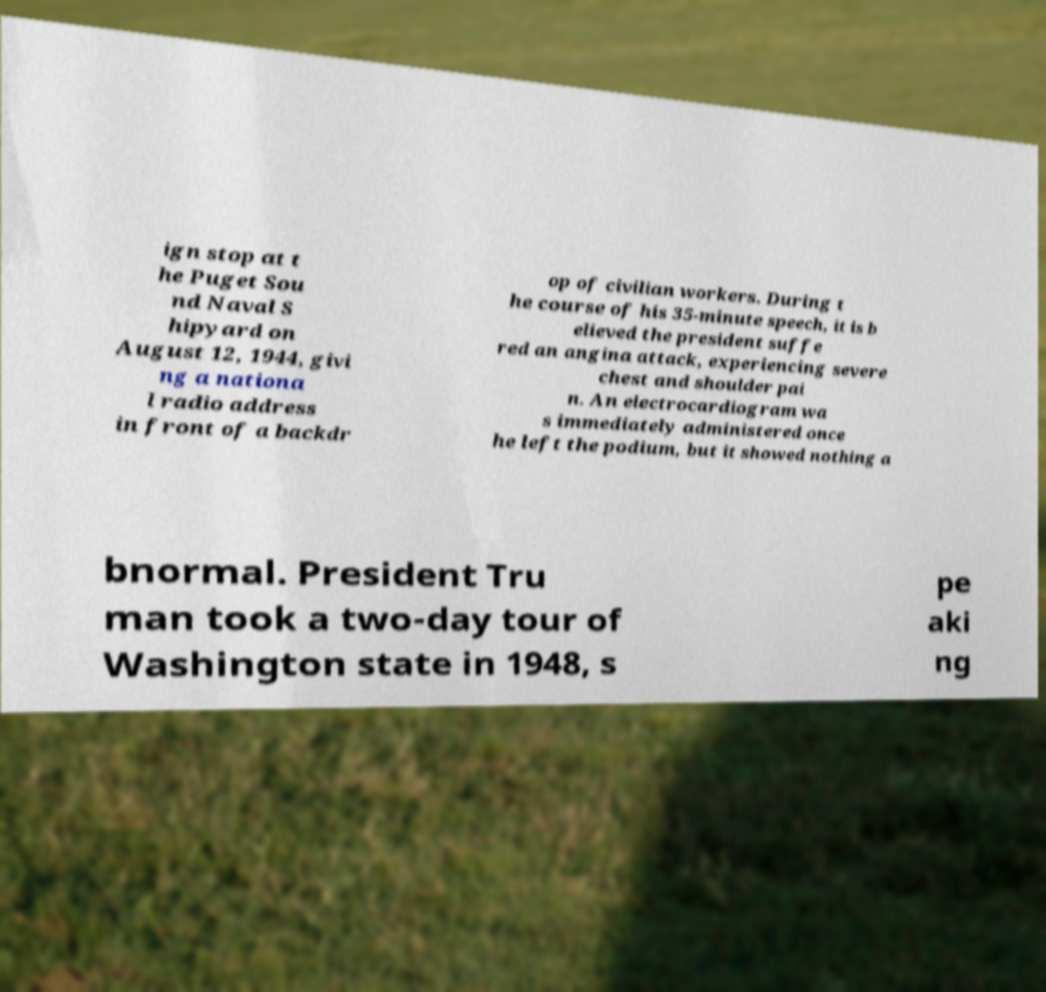There's text embedded in this image that I need extracted. Can you transcribe it verbatim? ign stop at t he Puget Sou nd Naval S hipyard on August 12, 1944, givi ng a nationa l radio address in front of a backdr op of civilian workers. During t he course of his 35-minute speech, it is b elieved the president suffe red an angina attack, experiencing severe chest and shoulder pai n. An electrocardiogram wa s immediately administered once he left the podium, but it showed nothing a bnormal. President Tru man took a two-day tour of Washington state in 1948, s pe aki ng 